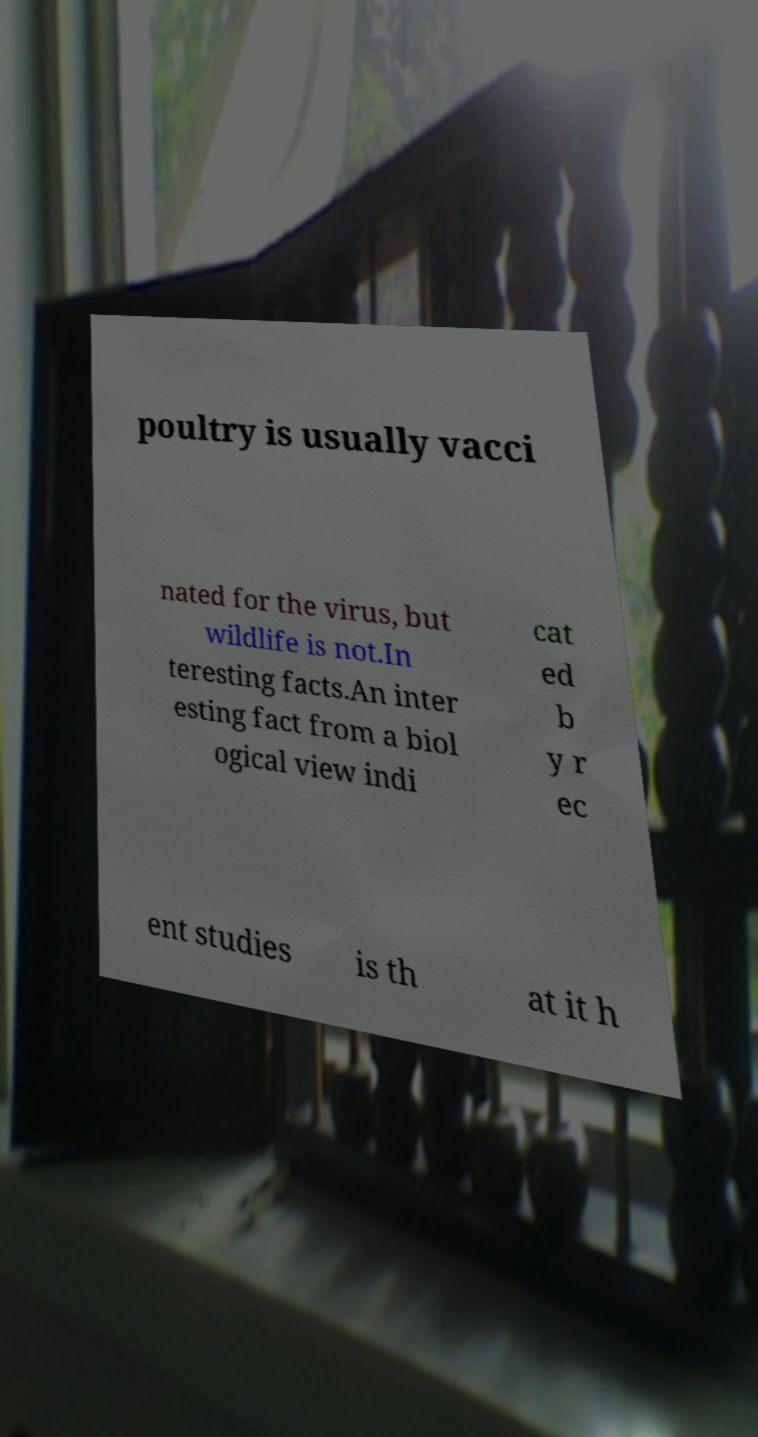What messages or text are displayed in this image? I need them in a readable, typed format. poultry is usually vacci nated for the virus, but wildlife is not.In teresting facts.An inter esting fact from a biol ogical view indi cat ed b y r ec ent studies is th at it h 